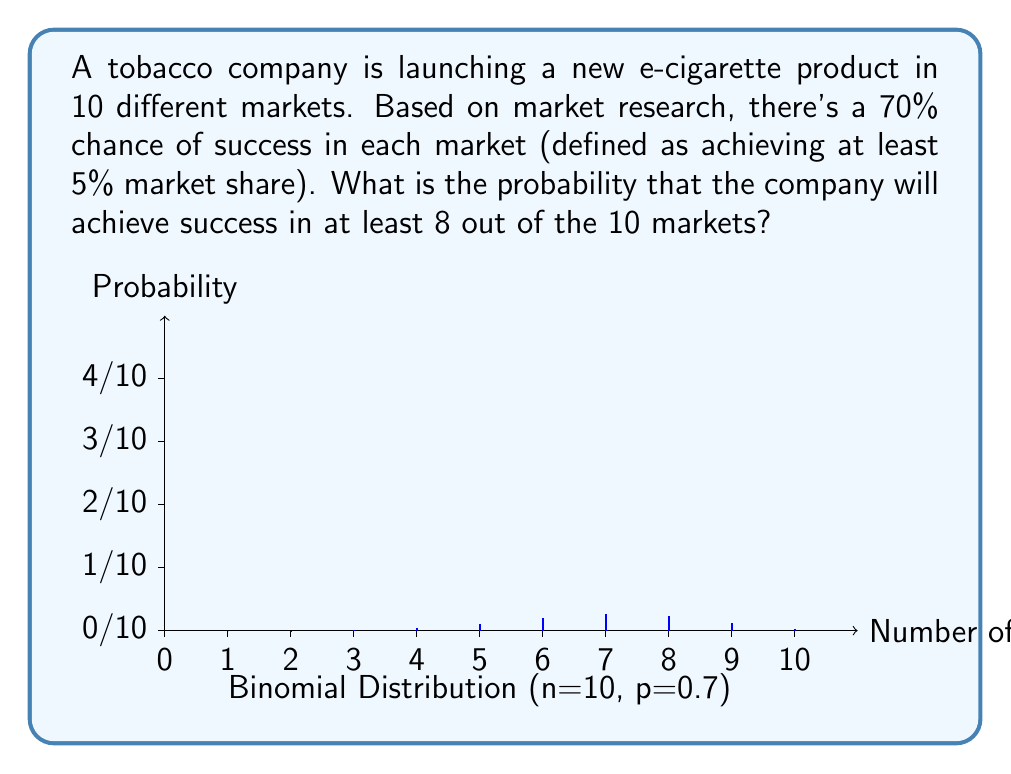Solve this math problem. To solve this problem, we'll use the binomial distribution. Let's break it down step-by-step:

1) We have a binomial distribution with the following parameters:
   $n = 10$ (number of markets)
   $p = 0.7$ (probability of success in each market)
   We want to find $P(X \geq 8)$, where $X$ is the number of successes.

2) The binomial probability mass function is:
   $$P(X = k) = \binom{n}{k} p^k (1-p)^{n-k}$$

3) We need to calculate:
   $$P(X \geq 8) = P(X = 8) + P(X = 9) + P(X = 10)$$

4) Let's calculate each probability:

   For $k = 8$:
   $$P(X = 8) = \binom{10}{8} (0.7)^8 (0.3)^2 = 45 \cdot 0.5764801 \cdot 0.09 = 0.2333767$$

   For $k = 9$:
   $$P(X = 9) = \binom{10}{9} (0.7)^9 (0.3)^1 = 10 \cdot 0.4034361 \cdot 0.3 = 0.1210308$$

   For $k = 10$:
   $$P(X = 10) = \binom{10}{10} (0.7)^{10} (0.3)^0 = 1 \cdot 0.2824295 \cdot 1 = 0.2824295$$

5) Sum these probabilities:
   $$P(X \geq 8) = 0.2333767 + 0.1210308 + 0.2824295 = 0.6368370$$

Therefore, the probability of achieving success in at least 8 out of 10 markets is approximately 0.6368 or 63.68%.
Answer: 0.6368 